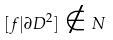Convert formula to latex. <formula><loc_0><loc_0><loc_500><loc_500>[ f | \partial D ^ { 2 } ] \notin N</formula> 